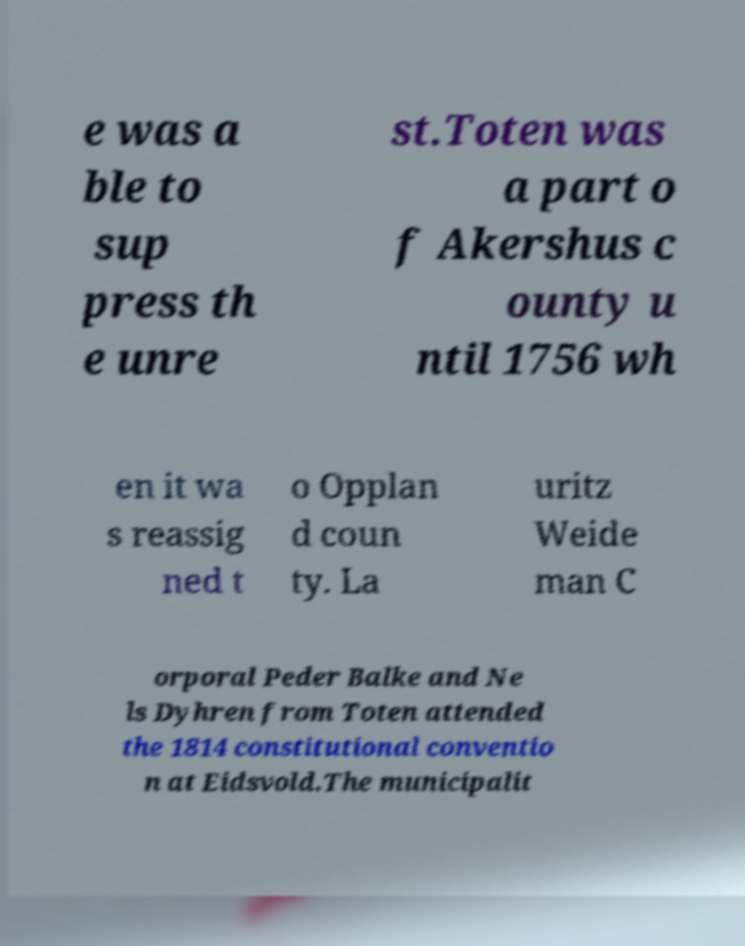For documentation purposes, I need the text within this image transcribed. Could you provide that? e was a ble to sup press th e unre st.Toten was a part o f Akershus c ounty u ntil 1756 wh en it wa s reassig ned t o Opplan d coun ty. La uritz Weide man C orporal Peder Balke and Ne ls Dyhren from Toten attended the 1814 constitutional conventio n at Eidsvold.The municipalit 